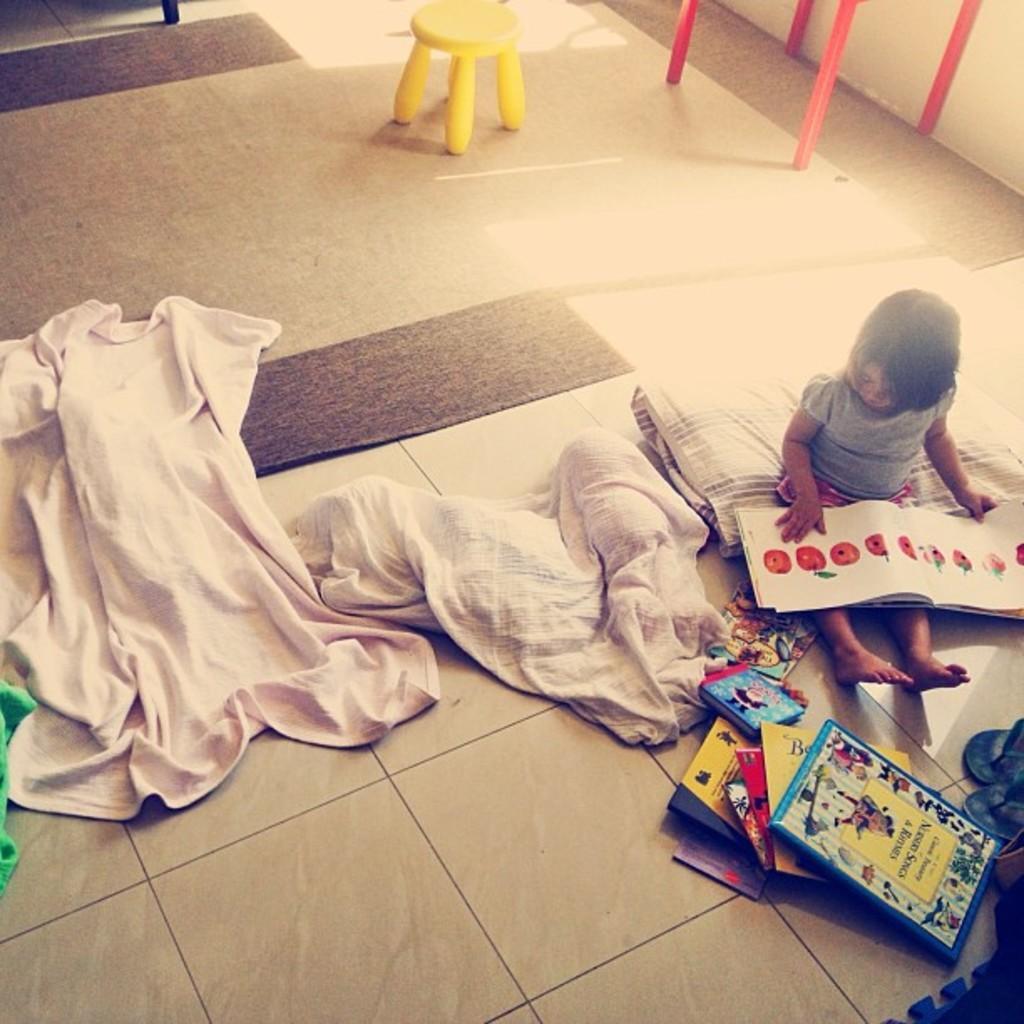In one or two sentences, can you explain what this image depicts? In this picture I can observe a baby sitting on the floor. There are some clothes on the floor. In front of the baby I can observe some books. In the background I can observe yellow color stool on the floor. 